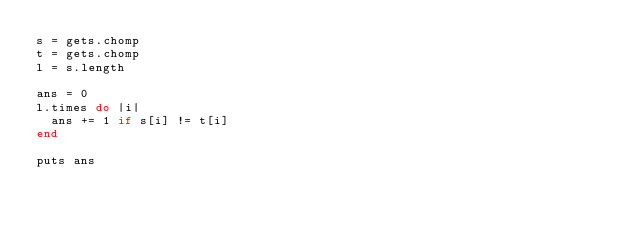Convert code to text. <code><loc_0><loc_0><loc_500><loc_500><_Ruby_>s = gets.chomp
t = gets.chomp
l = s.length

ans = 0
l.times do |i|
  ans += 1 if s[i] != t[i]
end

puts ans
</code> 